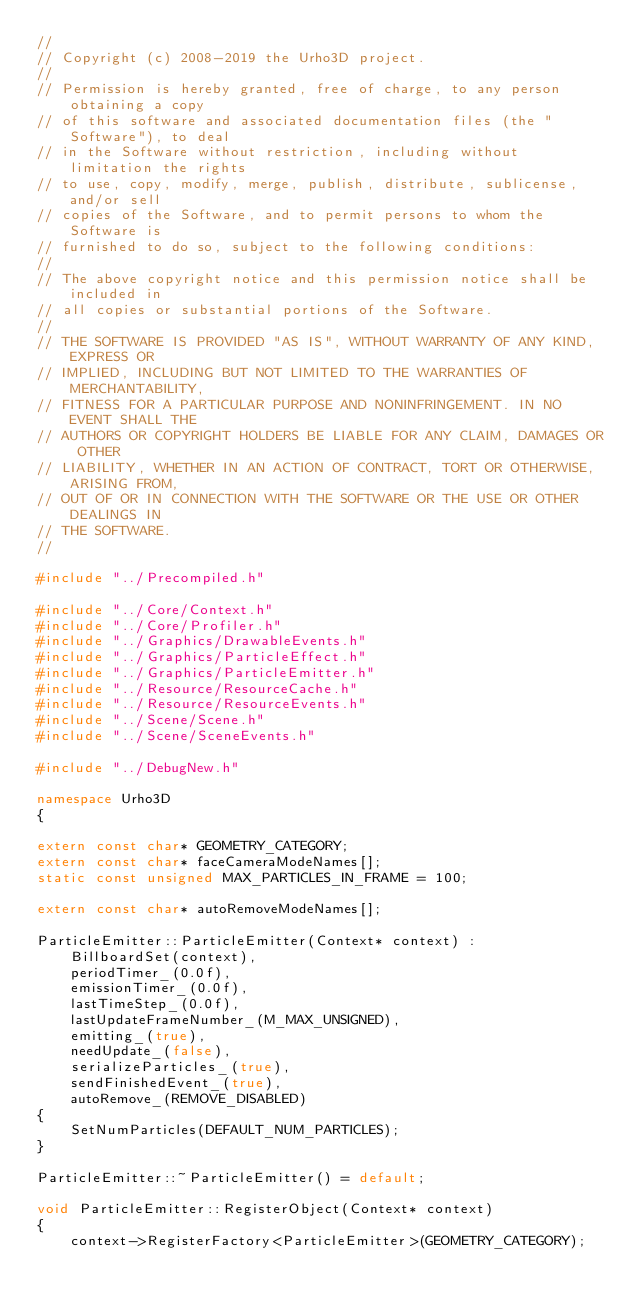Convert code to text. <code><loc_0><loc_0><loc_500><loc_500><_C++_>//
// Copyright (c) 2008-2019 the Urho3D project.
//
// Permission is hereby granted, free of charge, to any person obtaining a copy
// of this software and associated documentation files (the "Software"), to deal
// in the Software without restriction, including without limitation the rights
// to use, copy, modify, merge, publish, distribute, sublicense, and/or sell
// copies of the Software, and to permit persons to whom the Software is
// furnished to do so, subject to the following conditions:
//
// The above copyright notice and this permission notice shall be included in
// all copies or substantial portions of the Software.
//
// THE SOFTWARE IS PROVIDED "AS IS", WITHOUT WARRANTY OF ANY KIND, EXPRESS OR
// IMPLIED, INCLUDING BUT NOT LIMITED TO THE WARRANTIES OF MERCHANTABILITY,
// FITNESS FOR A PARTICULAR PURPOSE AND NONINFRINGEMENT. IN NO EVENT SHALL THE
// AUTHORS OR COPYRIGHT HOLDERS BE LIABLE FOR ANY CLAIM, DAMAGES OR OTHER
// LIABILITY, WHETHER IN AN ACTION OF CONTRACT, TORT OR OTHERWISE, ARISING FROM,
// OUT OF OR IN CONNECTION WITH THE SOFTWARE OR THE USE OR OTHER DEALINGS IN
// THE SOFTWARE.
//

#include "../Precompiled.h"

#include "../Core/Context.h"
#include "../Core/Profiler.h"
#include "../Graphics/DrawableEvents.h"
#include "../Graphics/ParticleEffect.h"
#include "../Graphics/ParticleEmitter.h"
#include "../Resource/ResourceCache.h"
#include "../Resource/ResourceEvents.h"
#include "../Scene/Scene.h"
#include "../Scene/SceneEvents.h"

#include "../DebugNew.h"

namespace Urho3D
{

extern const char* GEOMETRY_CATEGORY;
extern const char* faceCameraModeNames[];
static const unsigned MAX_PARTICLES_IN_FRAME = 100;

extern const char* autoRemoveModeNames[];

ParticleEmitter::ParticleEmitter(Context* context) :
    BillboardSet(context),
    periodTimer_(0.0f),
    emissionTimer_(0.0f),
    lastTimeStep_(0.0f),
    lastUpdateFrameNumber_(M_MAX_UNSIGNED),
    emitting_(true),
    needUpdate_(false),
    serializeParticles_(true),
    sendFinishedEvent_(true),
    autoRemove_(REMOVE_DISABLED)
{
    SetNumParticles(DEFAULT_NUM_PARTICLES);
}

ParticleEmitter::~ParticleEmitter() = default;

void ParticleEmitter::RegisterObject(Context* context)
{
    context->RegisterFactory<ParticleEmitter>(GEOMETRY_CATEGORY);
</code> 